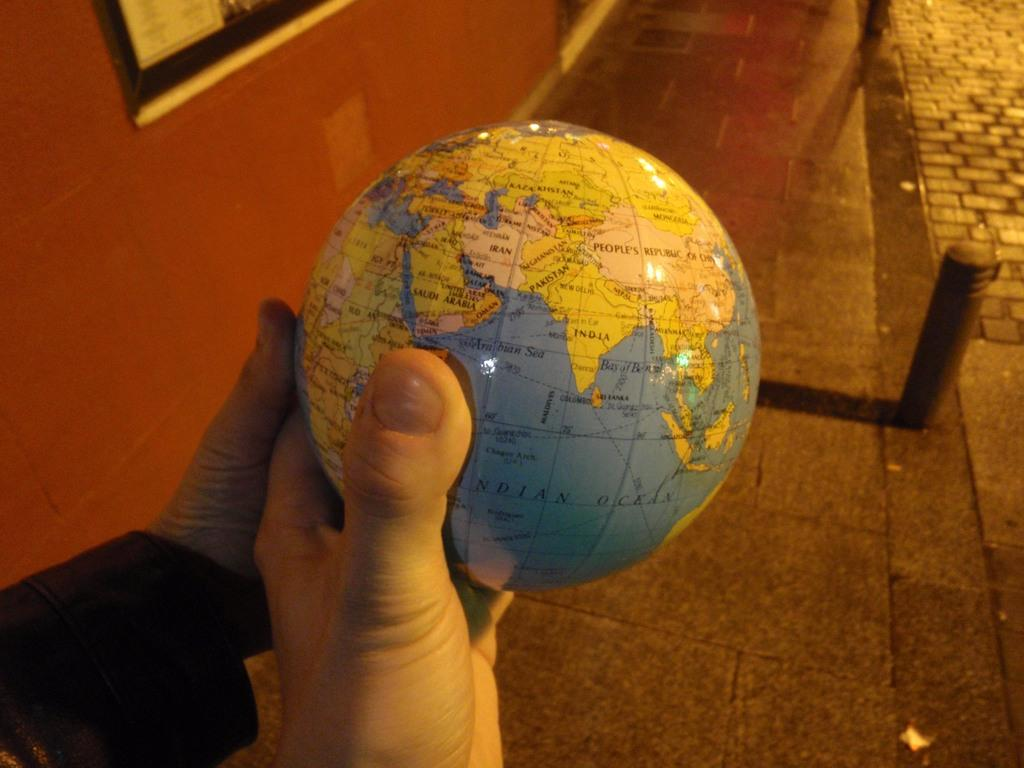How many people are in the image? There are two persons in the image. What are the persons holding in the image? The persons are holding a globe. What can be seen in the background of the image? There is a pavement with poles in the background. What is attached to the wall on the left side of the image? There is a wall with a frame attached to it on the left side. What type of wool is being used to make the bed in the image? There is no wool or bed present in the image. How many heads are visible in the image? There is no head visible in the image; only two persons holding a globe are present. 